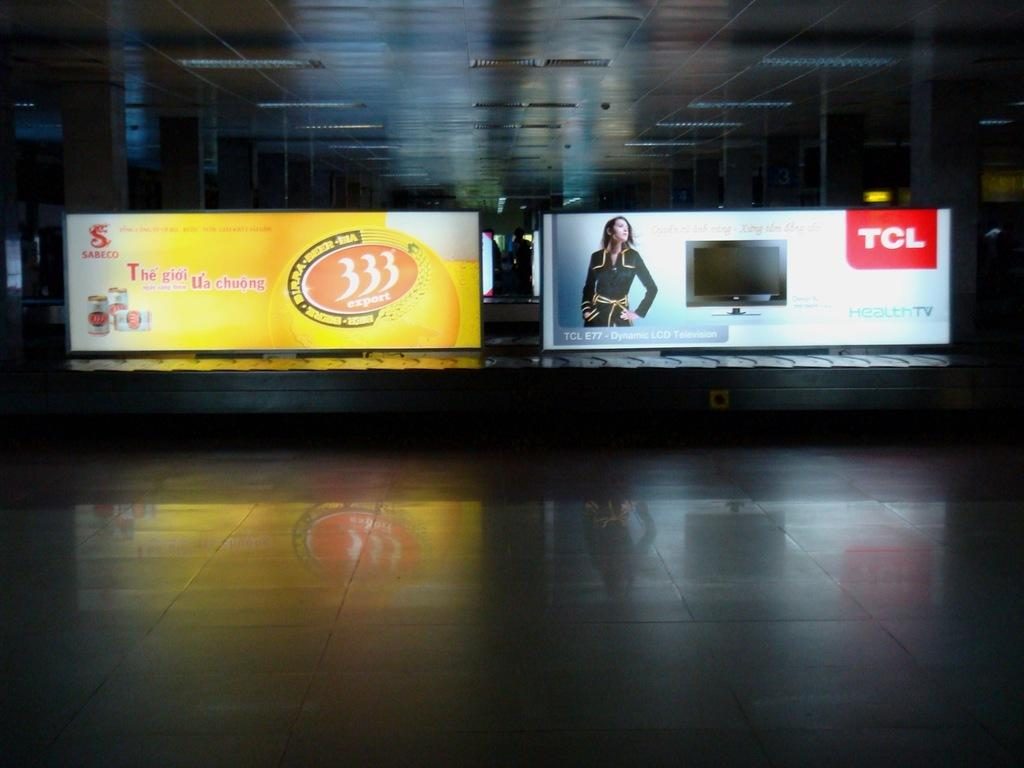<image>
Describe the image concisely. the billboard to the right ss for a TCL TV and the 